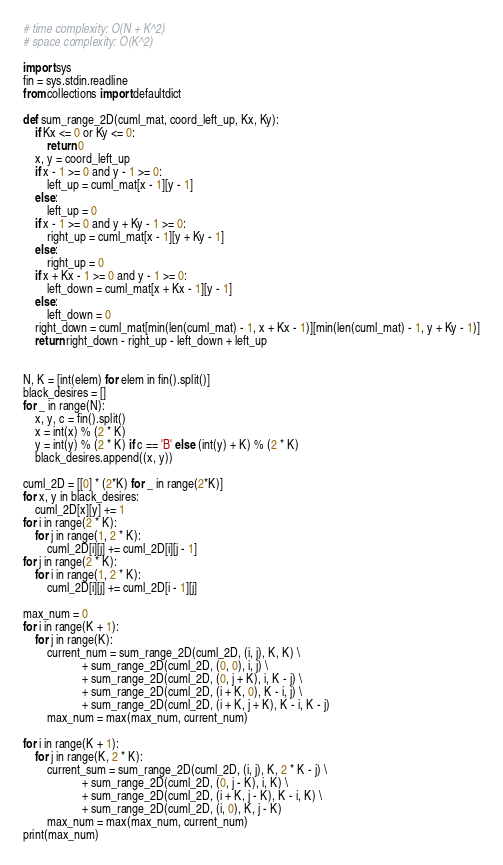<code> <loc_0><loc_0><loc_500><loc_500><_Python_># time complexity: O(N + K^2)
# space complexity: O(K^2)

import sys
fin = sys.stdin.readline
from collections import defaultdict

def sum_range_2D(cuml_mat, coord_left_up, Kx, Ky):
    if Kx <= 0 or Ky <= 0:
        return 0
    x, y = coord_left_up
    if x - 1 >= 0 and y - 1 >= 0:
        left_up = cuml_mat[x - 1][y - 1]
    else:
        left_up = 0
    if x - 1 >= 0 and y + Ky - 1 >= 0:
        right_up = cuml_mat[x - 1][y + Ky - 1]
    else:
        right_up = 0
    if x + Kx - 1 >= 0 and y - 1 >= 0:
        left_down = cuml_mat[x + Kx - 1][y - 1]
    else:
        left_down = 0
    right_down = cuml_mat[min(len(cuml_mat) - 1, x + Kx - 1)][min(len(cuml_mat) - 1, y + Ky - 1)]
    return right_down - right_up - left_down + left_up


N, K = [int(elem) for elem in fin().split()]
black_desires = []
for _ in range(N):
    x, y, c = fin().split()
    x = int(x) % (2 * K)
    y = int(y) % (2 * K) if c == 'B' else (int(y) + K) % (2 * K)
    black_desires.append((x, y))

cuml_2D = [[0] * (2*K) for _ in range(2*K)]
for x, y in black_desires:
    cuml_2D[x][y] += 1
for i in range(2 * K):
    for j in range(1, 2 * K):
        cuml_2D[i][j] += cuml_2D[i][j - 1]
for j in range(2 * K):
    for i in range(1, 2 * K):
        cuml_2D[i][j] += cuml_2D[i - 1][j]

max_num = 0
for i in range(K + 1):
    for j in range(K):
        current_num = sum_range_2D(cuml_2D, (i, j), K, K) \
                    + sum_range_2D(cuml_2D, (0, 0), i, j) \
                    + sum_range_2D(cuml_2D, (0, j + K), i, K - j) \
                    + sum_range_2D(cuml_2D, (i + K, 0), K - i, j) \
                    + sum_range_2D(cuml_2D, (i + K, j + K), K - i, K - j)
        max_num = max(max_num, current_num)

for i in range(K + 1):
    for j in range(K, 2 * K):
        current_sum = sum_range_2D(cuml_2D, (i, j), K, 2 * K - j) \
                    + sum_range_2D(cuml_2D, (0, j - K), i, K) \
                    + sum_range_2D(cuml_2D, (i + K, j - K), K - i, K) \
                    + sum_range_2D(cuml_2D, (i, 0), K, j - K)
        max_num = max(max_num, current_num)
print(max_num)</code> 